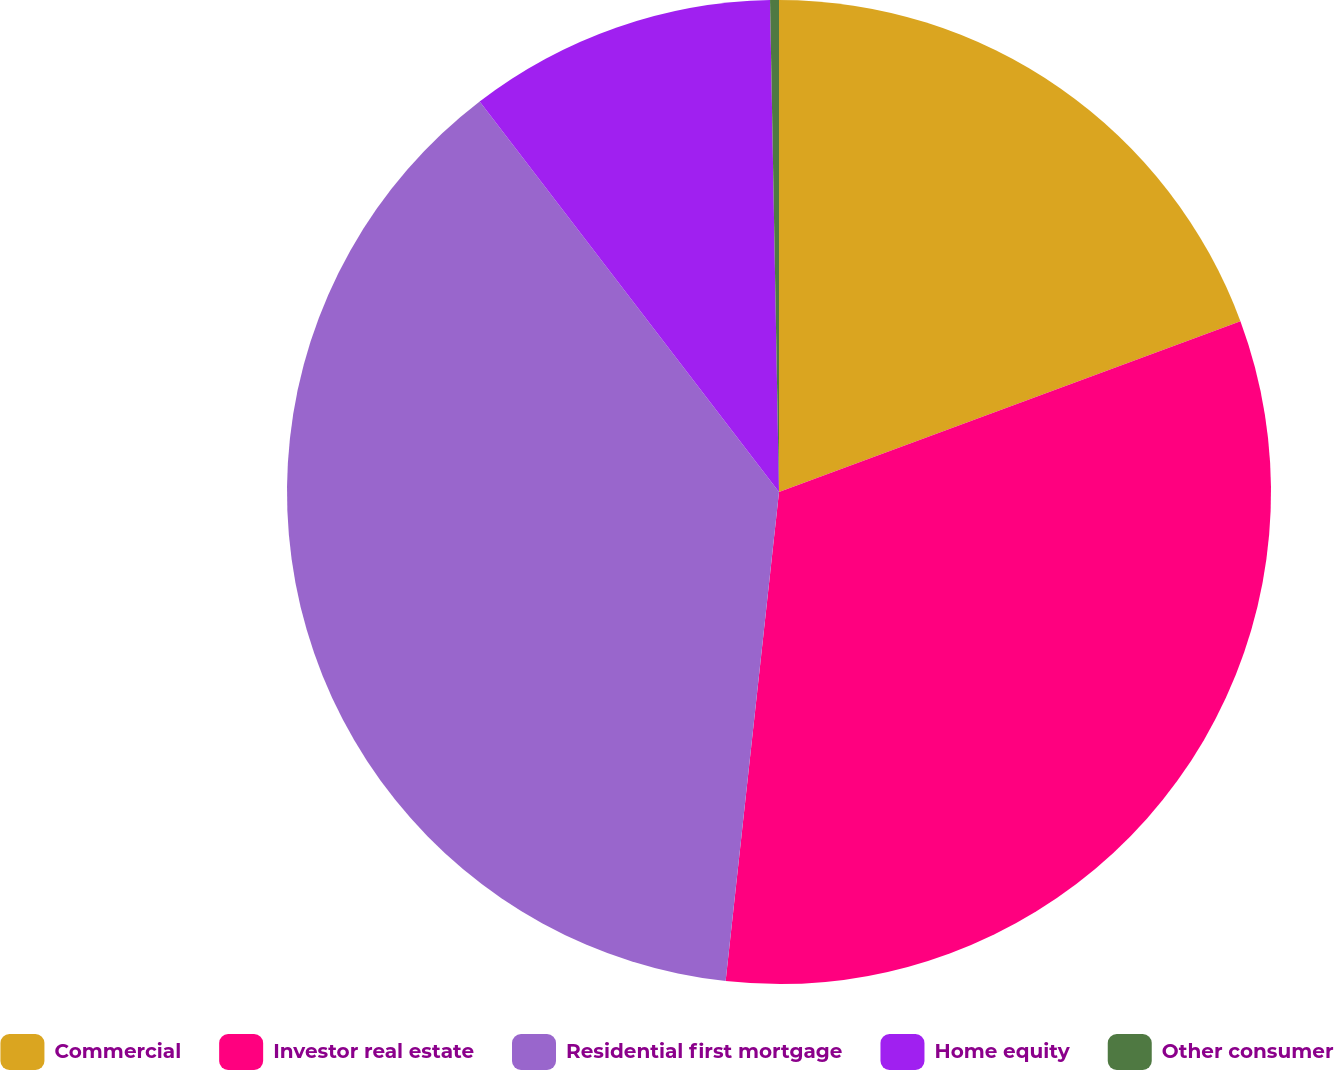<chart> <loc_0><loc_0><loc_500><loc_500><pie_chart><fcel>Commercial<fcel>Investor real estate<fcel>Residential first mortgage<fcel>Home equity<fcel>Other consumer<nl><fcel>19.36%<fcel>32.37%<fcel>37.86%<fcel>10.12%<fcel>0.29%<nl></chart> 